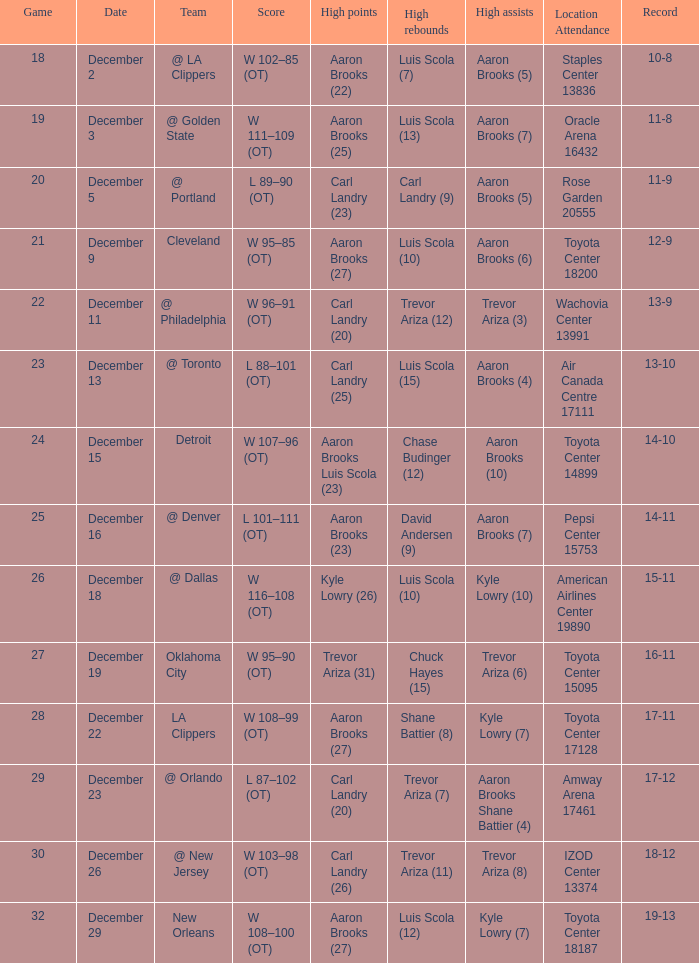What's the end score of the game where Shane Battier (8) did the high rebounds? W 108–99 (OT). Can you parse all the data within this table? {'header': ['Game', 'Date', 'Team', 'Score', 'High points', 'High rebounds', 'High assists', 'Location Attendance', 'Record'], 'rows': [['18', 'December 2', '@ LA Clippers', 'W 102–85 (OT)', 'Aaron Brooks (22)', 'Luis Scola (7)', 'Aaron Brooks (5)', 'Staples Center 13836', '10-8'], ['19', 'December 3', '@ Golden State', 'W 111–109 (OT)', 'Aaron Brooks (25)', 'Luis Scola (13)', 'Aaron Brooks (7)', 'Oracle Arena 16432', '11-8'], ['20', 'December 5', '@ Portland', 'L 89–90 (OT)', 'Carl Landry (23)', 'Carl Landry (9)', 'Aaron Brooks (5)', 'Rose Garden 20555', '11-9'], ['21', 'December 9', 'Cleveland', 'W 95–85 (OT)', 'Aaron Brooks (27)', 'Luis Scola (10)', 'Aaron Brooks (6)', 'Toyota Center 18200', '12-9'], ['22', 'December 11', '@ Philadelphia', 'W 96–91 (OT)', 'Carl Landry (20)', 'Trevor Ariza (12)', 'Trevor Ariza (3)', 'Wachovia Center 13991', '13-9'], ['23', 'December 13', '@ Toronto', 'L 88–101 (OT)', 'Carl Landry (25)', 'Luis Scola (15)', 'Aaron Brooks (4)', 'Air Canada Centre 17111', '13-10'], ['24', 'December 15', 'Detroit', 'W 107–96 (OT)', 'Aaron Brooks Luis Scola (23)', 'Chase Budinger (12)', 'Aaron Brooks (10)', 'Toyota Center 14899', '14-10'], ['25', 'December 16', '@ Denver', 'L 101–111 (OT)', 'Aaron Brooks (23)', 'David Andersen (9)', 'Aaron Brooks (7)', 'Pepsi Center 15753', '14-11'], ['26', 'December 18', '@ Dallas', 'W 116–108 (OT)', 'Kyle Lowry (26)', 'Luis Scola (10)', 'Kyle Lowry (10)', 'American Airlines Center 19890', '15-11'], ['27', 'December 19', 'Oklahoma City', 'W 95–90 (OT)', 'Trevor Ariza (31)', 'Chuck Hayes (15)', 'Trevor Ariza (6)', 'Toyota Center 15095', '16-11'], ['28', 'December 22', 'LA Clippers', 'W 108–99 (OT)', 'Aaron Brooks (27)', 'Shane Battier (8)', 'Kyle Lowry (7)', 'Toyota Center 17128', '17-11'], ['29', 'December 23', '@ Orlando', 'L 87–102 (OT)', 'Carl Landry (20)', 'Trevor Ariza (7)', 'Aaron Brooks Shane Battier (4)', 'Amway Arena 17461', '17-12'], ['30', 'December 26', '@ New Jersey', 'W 103–98 (OT)', 'Carl Landry (26)', 'Trevor Ariza (11)', 'Trevor Ariza (8)', 'IZOD Center 13374', '18-12'], ['32', 'December 29', 'New Orleans', 'W 108–100 (OT)', 'Aaron Brooks (27)', 'Luis Scola (12)', 'Kyle Lowry (7)', 'Toyota Center 18187', '19-13']]} 